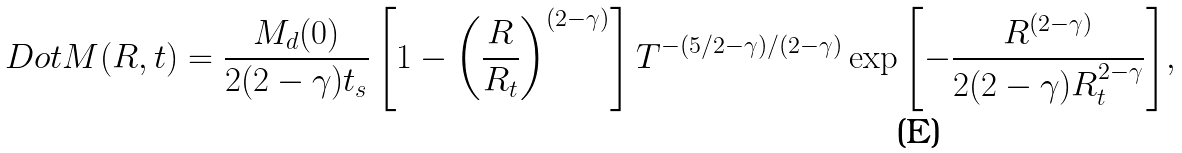<formula> <loc_0><loc_0><loc_500><loc_500>\ D o t { M } ( R , t ) = \frac { M _ { d } ( 0 ) } { 2 ( 2 - \gamma ) t _ { s } } \left [ 1 - \left ( \frac { R } { R _ { t } } \right ) ^ { ( 2 - \gamma ) } \right ] T ^ { - ( 5 / 2 - \gamma ) / ( 2 - \gamma ) } \exp { \left [ - \frac { R ^ { ( 2 - \gamma ) } } { 2 ( 2 - \gamma ) R _ { t } ^ { 2 - \gamma } } \right ] } ,</formula> 